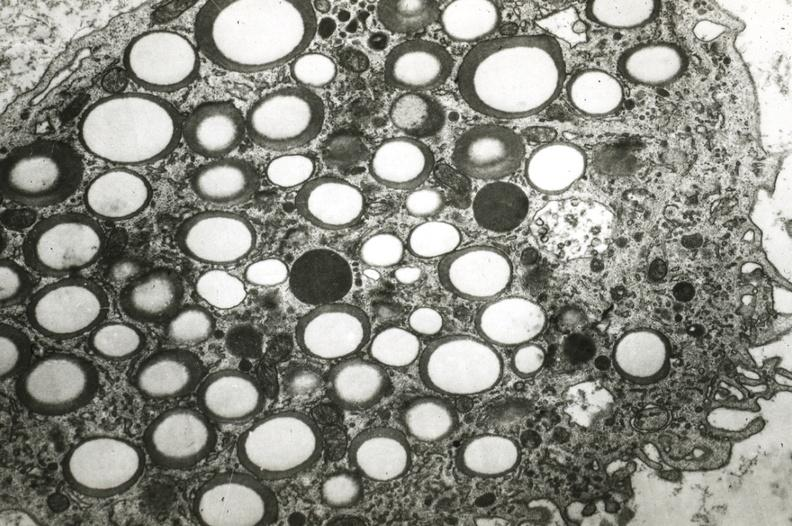s acute peritonitis present?
Answer the question using a single word or phrase. No 